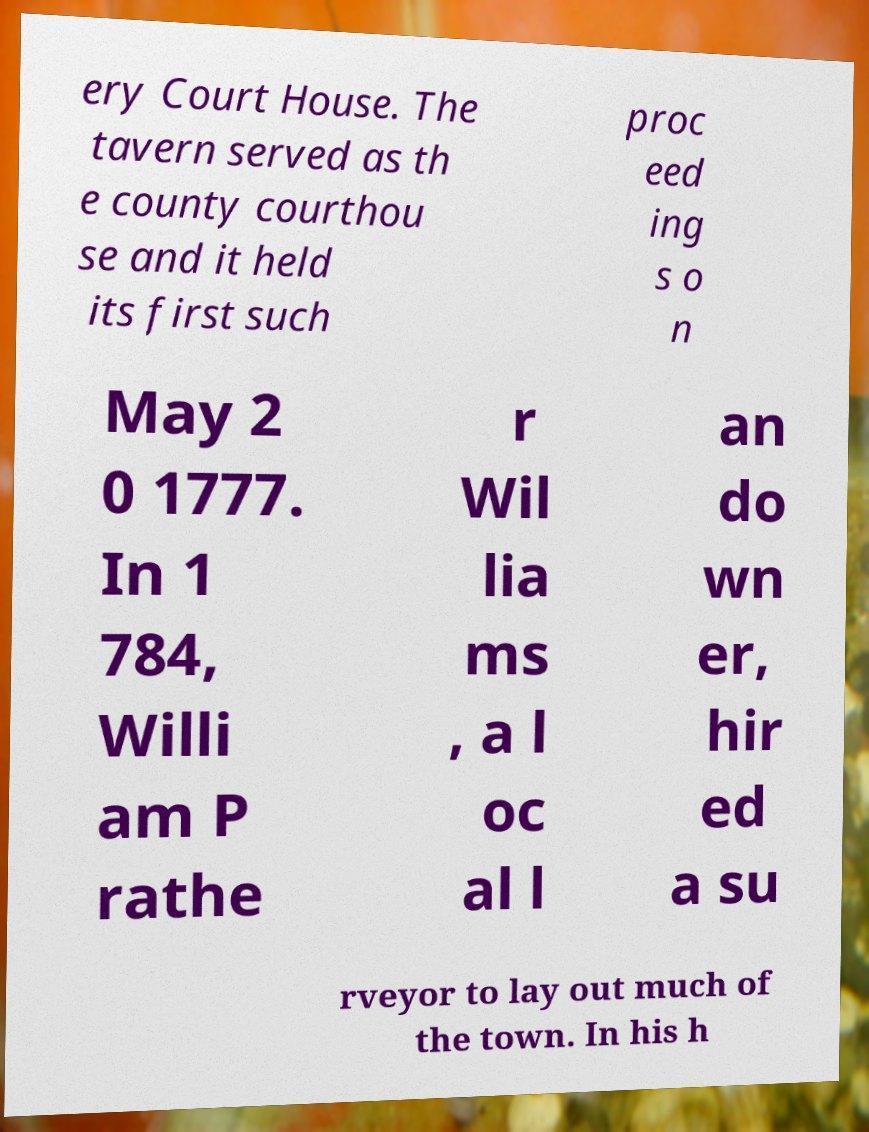Can you read and provide the text displayed in the image?This photo seems to have some interesting text. Can you extract and type it out for me? ery Court House. The tavern served as th e county courthou se and it held its first such proc eed ing s o n May 2 0 1777. In 1 784, Willi am P rathe r Wil lia ms , a l oc al l an do wn er, hir ed a su rveyor to lay out much of the town. In his h 